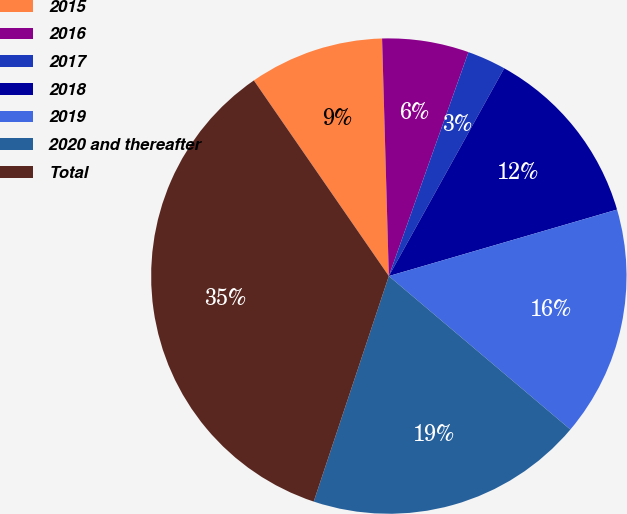<chart> <loc_0><loc_0><loc_500><loc_500><pie_chart><fcel>2015<fcel>2016<fcel>2017<fcel>2018<fcel>2019<fcel>2020 and thereafter<fcel>Total<nl><fcel>9.16%<fcel>5.89%<fcel>2.63%<fcel>12.42%<fcel>15.68%<fcel>18.95%<fcel>35.27%<nl></chart> 